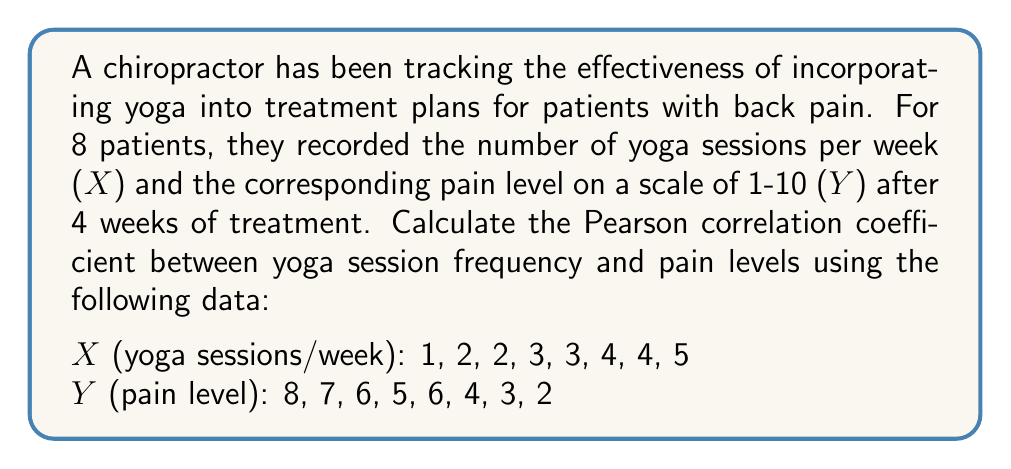Provide a solution to this math problem. To calculate the Pearson correlation coefficient (r), we'll use the formula:

$$ r = \frac{n\sum xy - \sum x \sum y}{\sqrt{[n\sum x^2 - (\sum x)^2][n\sum y^2 - (\sum y)^2]}} $$

Step 1: Calculate the sums and squared sums:
$\sum x = 24$, $\sum y = 41$, $\sum x^2 = 86$, $\sum y^2 = 237$

Step 2: Calculate $\sum xy$:
$\sum xy = 1(8) + 2(7) + 2(6) + 3(5) + 3(6) + 4(4) + 4(3) + 5(2) = 102$

Step 3: Insert values into the formula:
$$ r = \frac{8(102) - (24)(41)}{\sqrt{[8(86) - 24^2][8(237) - 41^2]}} $$

Step 4: Simplify:
$$ r = \frac{816 - 984}{\sqrt{(688 - 576)(1896 - 1681)}} = \frac{-168}{\sqrt{112 \cdot 215}} $$

Step 5: Calculate the final result:
$$ r = \frac{-168}{\sqrt{24080}} = \frac{-168}{155.18} \approx -0.9827 $$
Answer: $-0.9827$ 